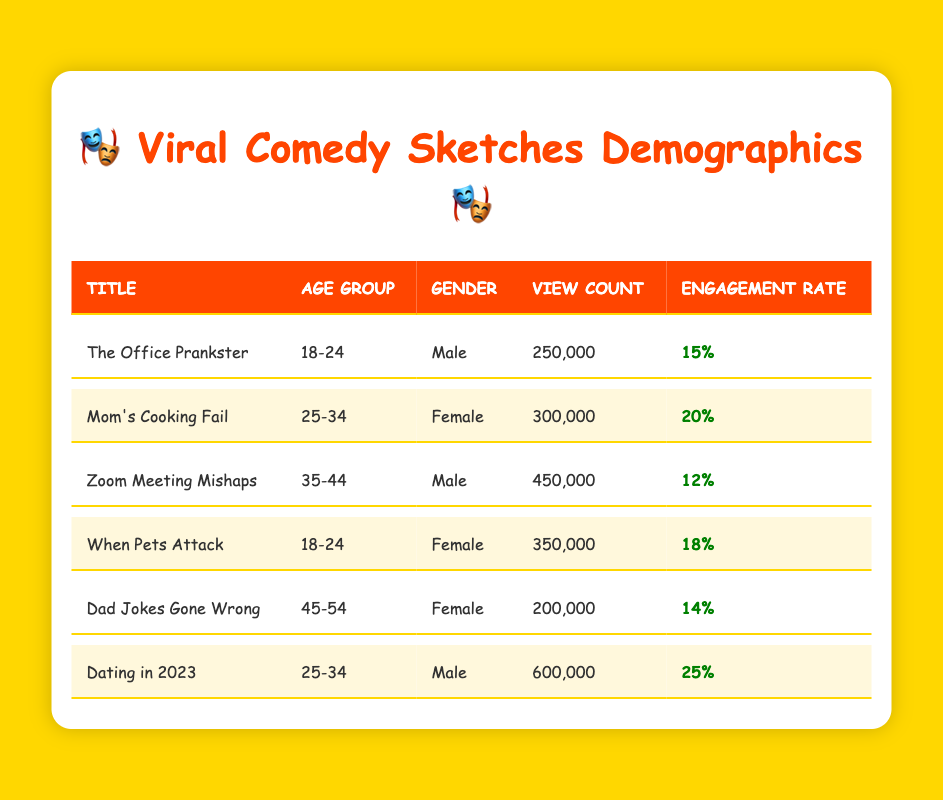What is the view count for "Dating in 2023"? The table shows that the view count for "Dating in 2023" is specifically listed in the row corresponding to this title, which indicates 600,000 views.
Answer: 600,000 How many sketches are targeted at the 18-24 age group? By looking at the table and counting the entries for the "Age Group" column where it says "18-24," we see that there are two sketches: "The Office Prankster" and "When Pets Attack."
Answer: 2 What is the engagement rate for "Mom's Cooking Fail"? The engagement rate for "Mom's Cooking Fail" is shown in the same row as its title, which indicates a rate of 20 percent.
Answer: 20% Which sketch has the highest view count and what is that count? A quick review of the view counts across all sketches reveals that "Dating in 2023" has the highest count at 600,000. This is derived from comparing all view counts listed in the table.
Answer: 600,000 Is there a sketch aimed at female viewers aged 45-54? Looking at the table, under the "Age Group" and "Gender" columns, "Dad Jokes Gone Wrong" is the only sketch aimed at female viewers aged 45-54, confirming that there is indeed one.
Answer: Yes What is the average view count for sketches in the 25-34 age group? For the age group 25-34, the view counts from "Mom's Cooking Fail" (300,000) and "Dating in 2023" (600,000) need to be averaged. Adding them gives 300,000 + 600,000 = 900,000, and dividing by 2 gives an average of 450,000.
Answer: 450,000 Which gender has a higher engagement rate overall? To find out which gender has a higher engagement rate, each sketch's engagement rates need to be reviewed by gender. For males, the rates are 15% (The Office Prankster), 12% (Zoom Meeting Mishaps), and 25% (Dating in 2023), averaging to 16.67%. For females, the rates are 20% (Mom's Cooking Fail), 18% (When Pets Attack), and 14% (Dad Jokes Gone Wrong), averaging to 17.33%. Since 17.33% is greater than 16.67%, females have a higher engagement rate overall.
Answer: Female How many sketches have engagement rates above 16%? Each sketch's engagement rate needs to be checked against the 16% threshold. "Mom's Cooking Fail" (20%), "When Pets Attack" (18%), and "Dating in 2023" (25%) exceed 16%. Counting these gives us three sketches with engagement rates above 16%.
Answer: 3 Which sketch has the lowest engagement rate and what is that rate? By reviewing the engagement rates in the table, "Zoom Meeting Mishaps" shows the lowest rate at 12 percent, which is confirmed by checking all sketches listed.
Answer: 12% 